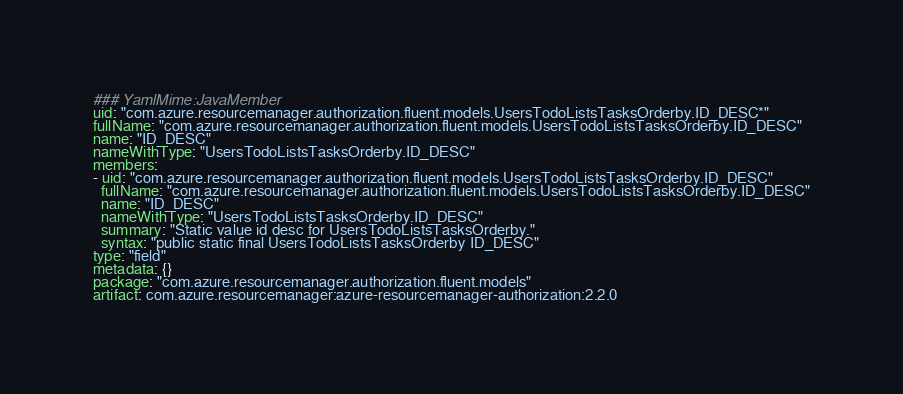Convert code to text. <code><loc_0><loc_0><loc_500><loc_500><_YAML_>### YamlMime:JavaMember
uid: "com.azure.resourcemanager.authorization.fluent.models.UsersTodoListsTasksOrderby.ID_DESC*"
fullName: "com.azure.resourcemanager.authorization.fluent.models.UsersTodoListsTasksOrderby.ID_DESC"
name: "ID_DESC"
nameWithType: "UsersTodoListsTasksOrderby.ID_DESC"
members:
- uid: "com.azure.resourcemanager.authorization.fluent.models.UsersTodoListsTasksOrderby.ID_DESC"
  fullName: "com.azure.resourcemanager.authorization.fluent.models.UsersTodoListsTasksOrderby.ID_DESC"
  name: "ID_DESC"
  nameWithType: "UsersTodoListsTasksOrderby.ID_DESC"
  summary: "Static value id desc for UsersTodoListsTasksOrderby."
  syntax: "public static final UsersTodoListsTasksOrderby ID_DESC"
type: "field"
metadata: {}
package: "com.azure.resourcemanager.authorization.fluent.models"
artifact: com.azure.resourcemanager:azure-resourcemanager-authorization:2.2.0
</code> 